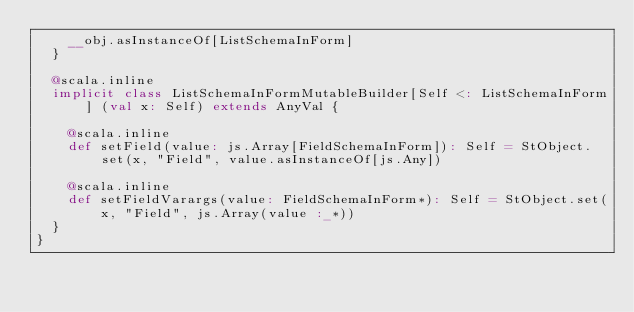Convert code to text. <code><loc_0><loc_0><loc_500><loc_500><_Scala_>    __obj.asInstanceOf[ListSchemaInForm]
  }
  
  @scala.inline
  implicit class ListSchemaInFormMutableBuilder[Self <: ListSchemaInForm] (val x: Self) extends AnyVal {
    
    @scala.inline
    def setField(value: js.Array[FieldSchemaInForm]): Self = StObject.set(x, "Field", value.asInstanceOf[js.Any])
    
    @scala.inline
    def setFieldVarargs(value: FieldSchemaInForm*): Self = StObject.set(x, "Field", js.Array(value :_*))
  }
}
</code> 